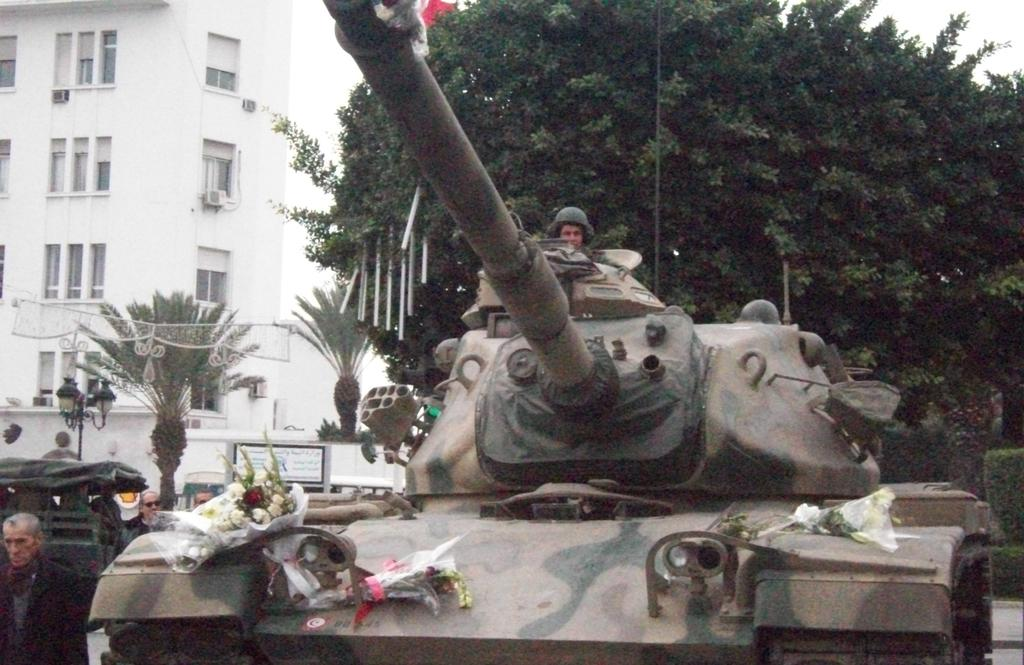What type of vehicle is in the image? There is a panzer in the image. What is placed on the panzer? Flower bouquets are on the panzer. Can you describe the person standing near the panzer? There is a person standing on the left side of the panzer. What can be seen in the background of the image? There are trees and a building in the background of the image. What type of structure is the person requesting to be built in the image? There is no mention of a structure or a request in the image. How many cows are visible in the image? There are no cows present in the image. 